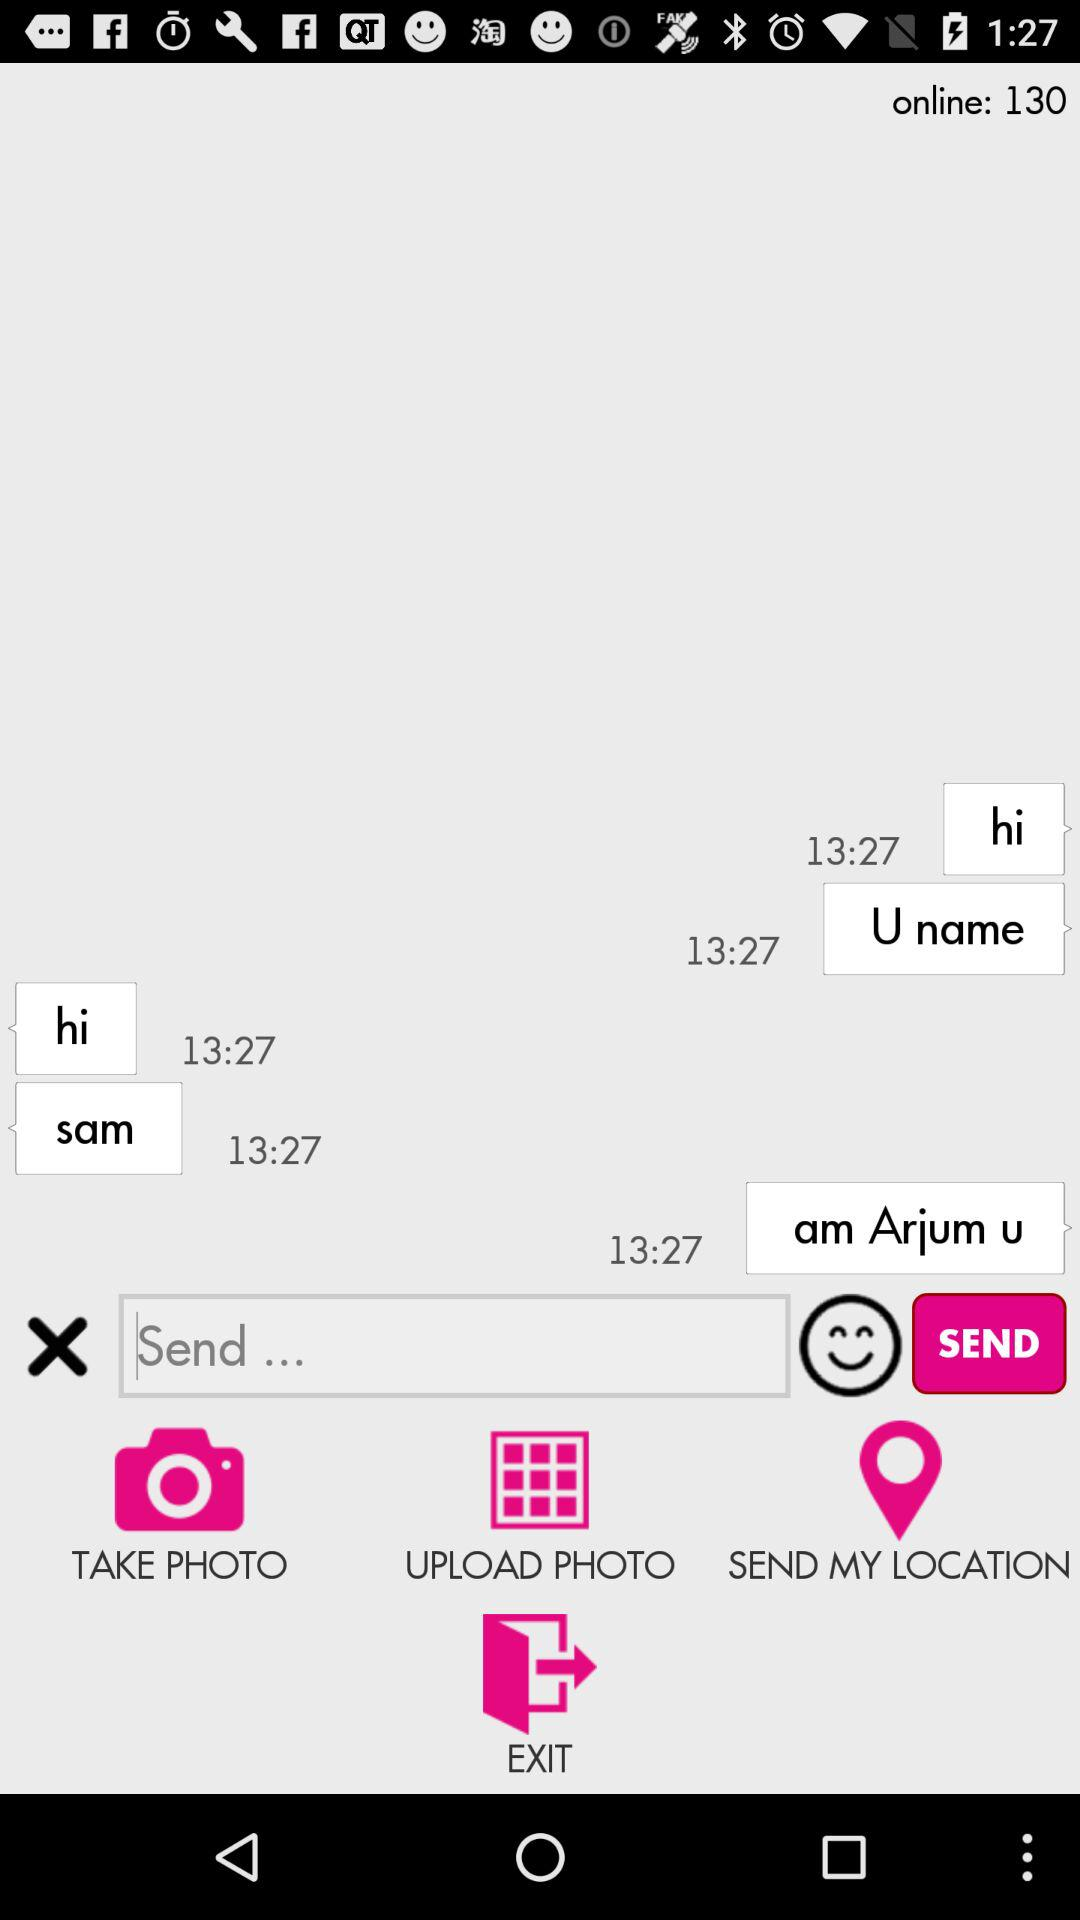How many people are in this conversation?
Answer the question using a single word or phrase. 2 